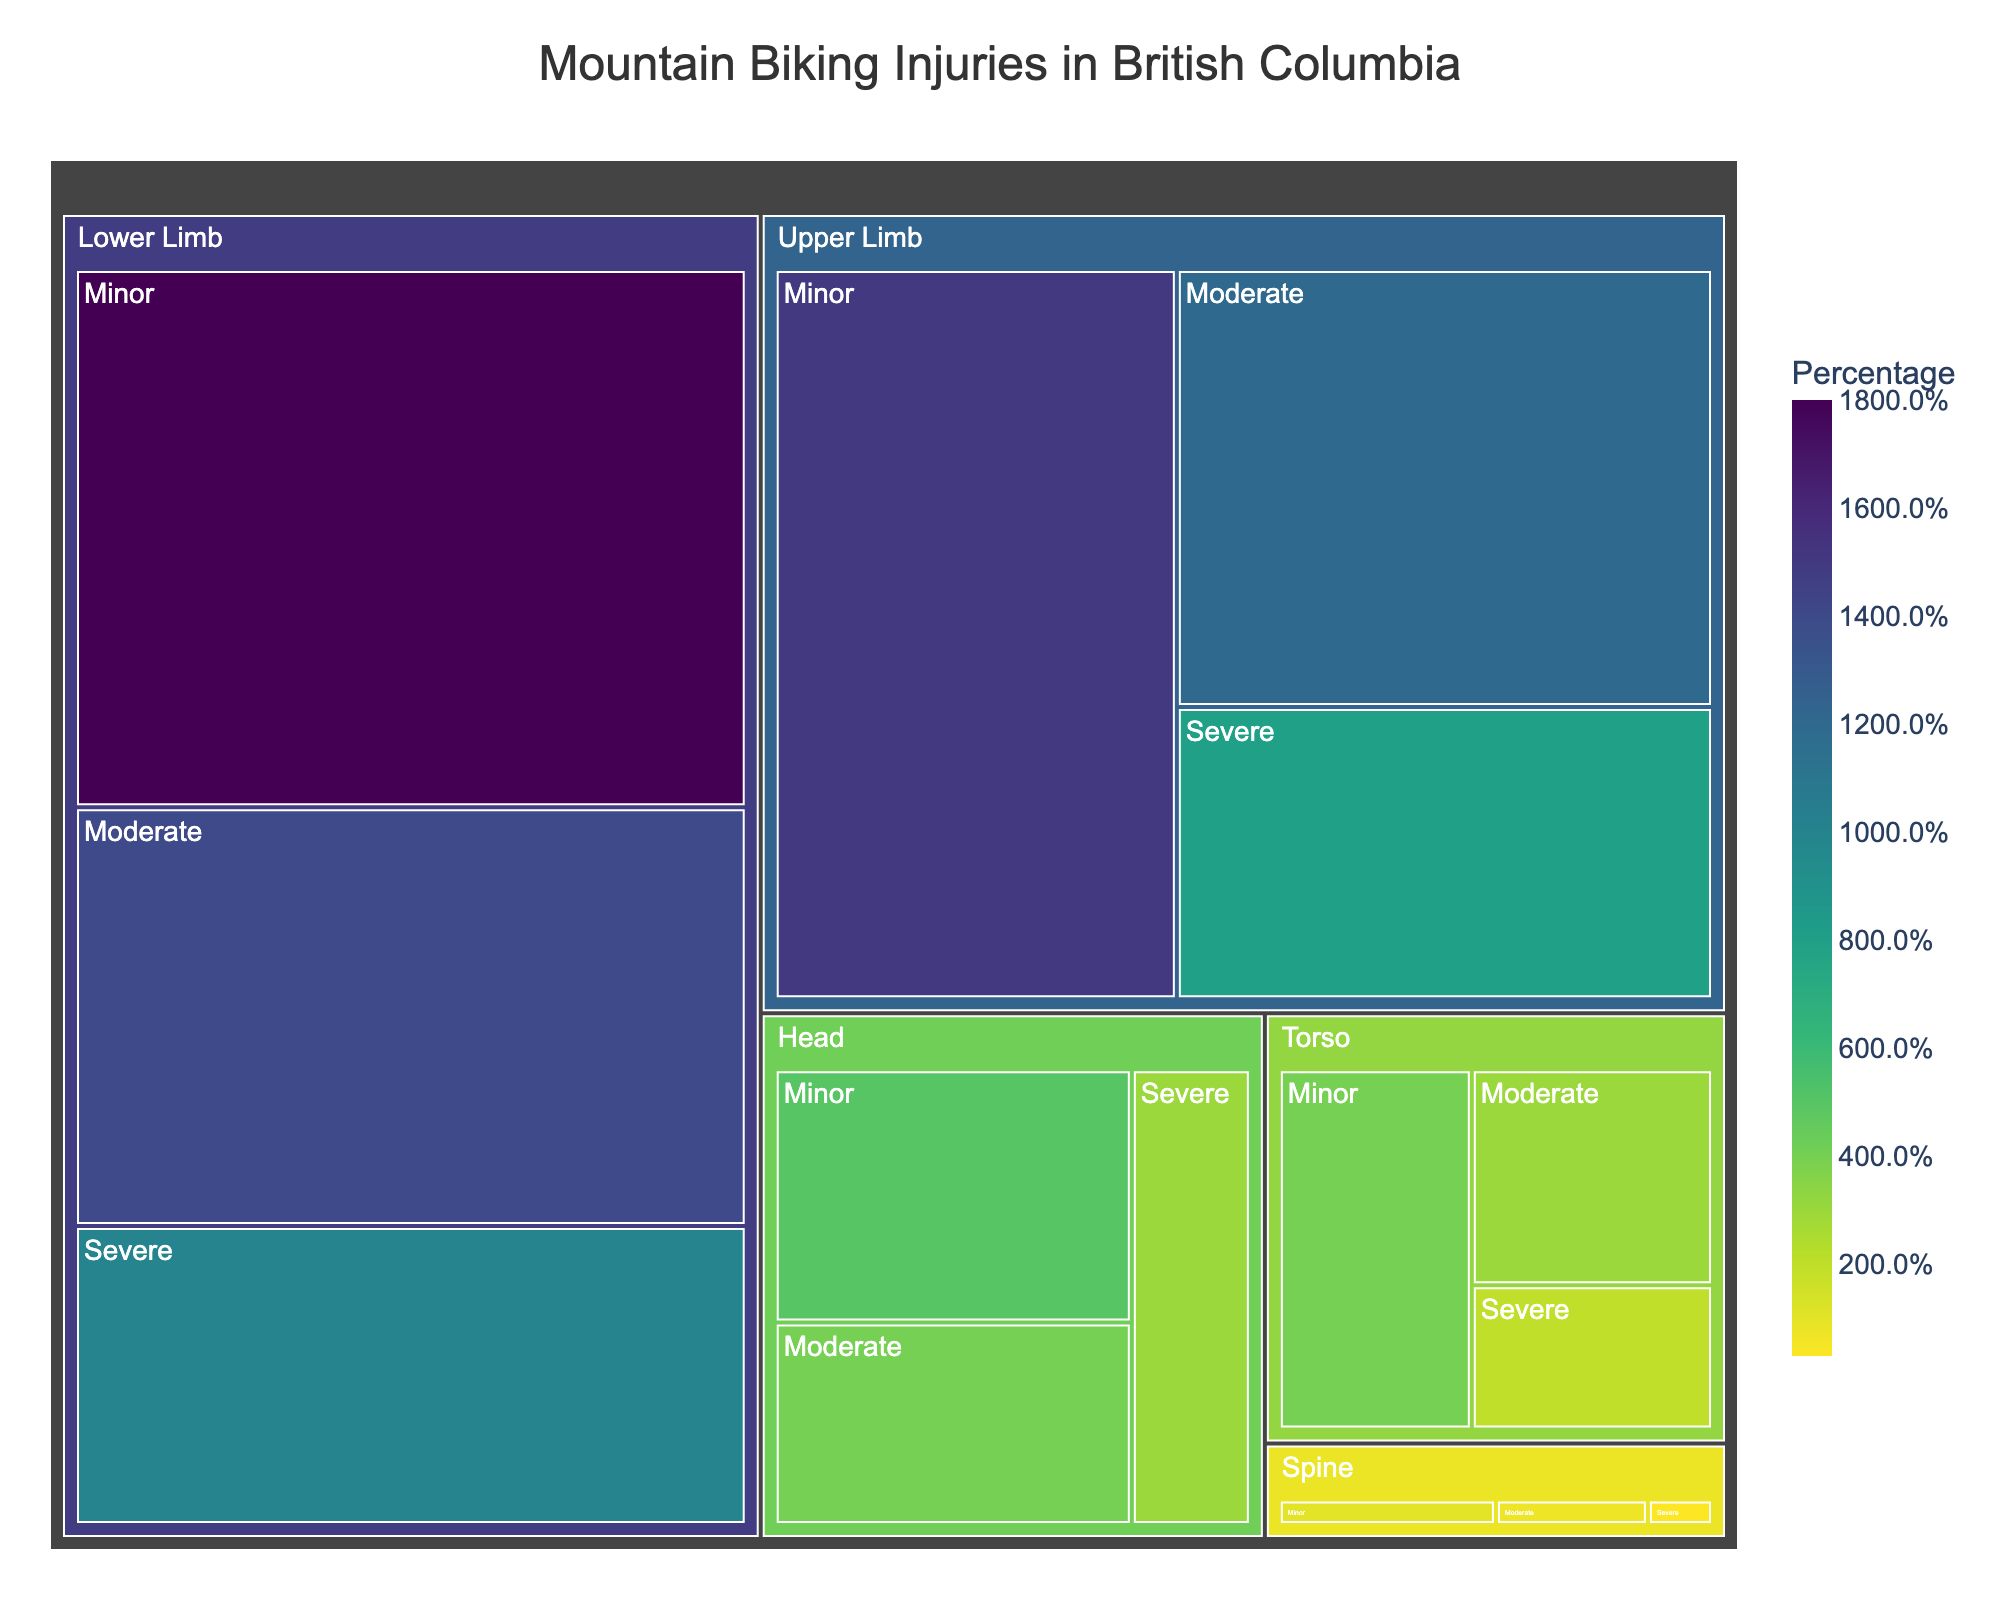How many different body parts are listed in the treemap? To answer this question, note the different categories at the top level of the hierarchy in the treemap.
Answer: 5 Which severity level has the highest percentage for Upper Limb injuries? Look at the different severity levels under the "Upper Limb" category and identify the one with the highest percentage.
Answer: Minor (15%) What is the combined percentage of severe injuries across all body parts? Sum the percentages of severe injuries for Upper Limb, Lower Limb, Head, Torso, and Spine. Calculation: 8 + 10 + 3 + 2 + 0.3
Answer: 23.3% Which body part has the lowest overall percentage of injuries? Identify the body part with the smallest representation in the treemap across all severity levels.
Answer: Spine Compare the percentage of minor injuries for Upper Limb and Lower Limb. Which one is higher? Look at the minor injury percentages for Upper Limb (15%) and Lower Limb (18%) and compare them.
Answer: Lower Limb (18%) What is the total percentage of injuries affecting the Head? Add the percentages for minor, moderate, and severe injuries in the Head category. Calculation: 5 + 4 + 3
Answer: 12% If we sum up moderate injuries for all body parts, what is the resulting percentage? Sum the percentages of moderate injuries for all body parts: Upper Limb (12%), Lower Limb (14%), Head (4%), Torso (3%), and Spine (0.7%). Calculation: 12 + 14 + 4 + 3 + 0.7
Answer: 33.7% Which body part has the highest percentage of moderate injuries? Identify the body part category with the highest moderate injury percentage by examining the treemap.
Answer: Lower Limb (14%) How do the percentages of severe injuries for Head and Torso compare? Compare the severe injury percentages for Head (3%) and Torso (2%).
Answer: Head has a higher percentage (3%) Calculate the difference in percentage between minor and severe injuries for the Upper Limb. Subtract the percentage of severe injuries from minor injuries for the Upper Limb category. Calculation: 15 - 8
Answer: 7% 